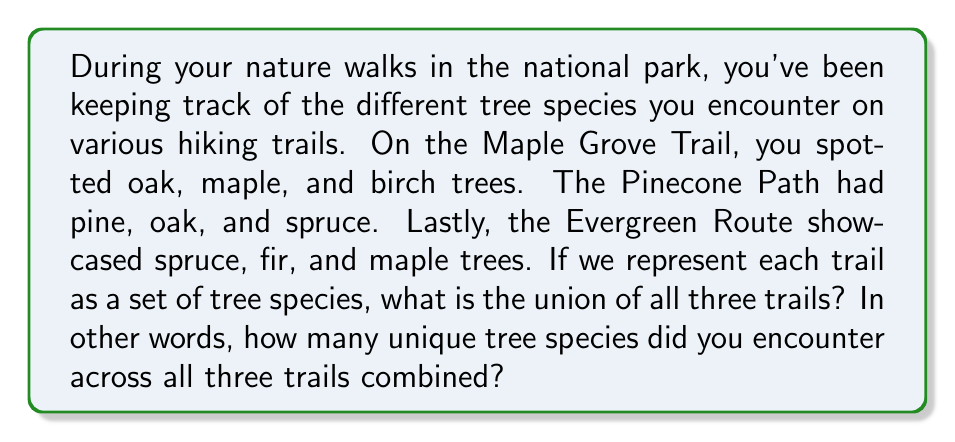Provide a solution to this math problem. Let's approach this step-by-step using set theory:

1) First, let's define our sets:
   Maple Grove Trail: $A = \{oak, maple, birch\}$
   Pinecone Path: $B = \{pine, oak, spruce\}$
   Evergreen Route: $C = \{spruce, fir, maple\}$

2) We need to find the union of these three sets, which we can represent as $A \cup B \cup C$. This union will include all unique elements that appear in any of the sets.

3) Let's list out all the elements, keeping track of which set(s) they appear in:
   - oak: in A and B
   - maple: in A and C
   - birch: in A only
   - pine: in B only
   - spruce: in B and C
   - fir: in C only

4) Counting the unique elements, we get:
   $\{oak, maple, birch, pine, spruce, fir\}$

5) Therefore, the union of all three trails contains 6 unique tree species.

This method of listing and counting unique elements is particularly suitable for small sets and aligns well with the persona of a retired teacher who might prefer a hands-on, visual approach to problem-solving.
Answer: The union of the tree species across all three trails contains 6 unique species: $|A \cup B \cup C| = 6$ 